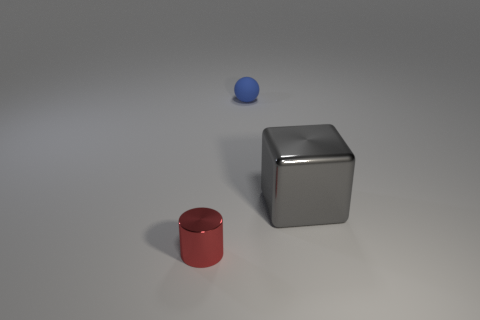Add 3 blue matte balls. How many objects exist? 6 Add 2 tiny objects. How many tiny objects are left? 4 Add 3 blue balls. How many blue balls exist? 4 Subtract 1 gray cubes. How many objects are left? 2 Subtract all cylinders. How many objects are left? 2 Subtract 1 blocks. How many blocks are left? 0 Subtract all red balls. Subtract all yellow cylinders. How many balls are left? 1 Subtract all small shiny blocks. Subtract all small objects. How many objects are left? 1 